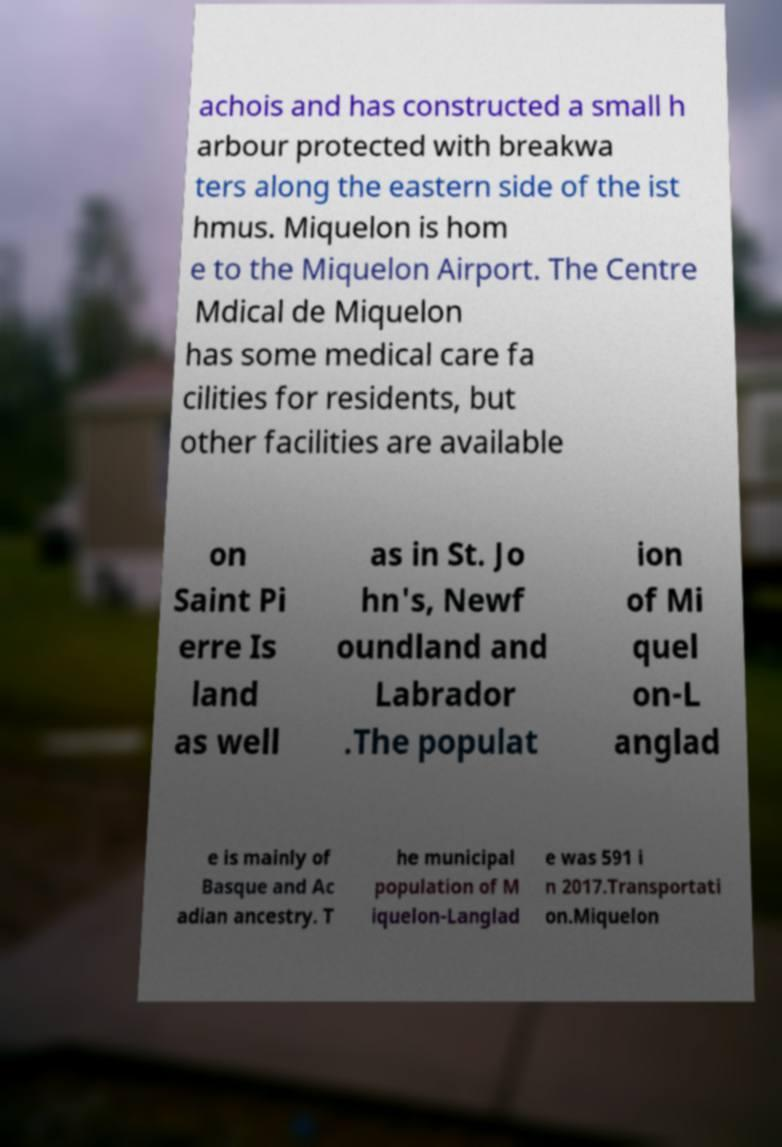Can you read and provide the text displayed in the image?This photo seems to have some interesting text. Can you extract and type it out for me? achois and has constructed a small h arbour protected with breakwa ters along the eastern side of the ist hmus. Miquelon is hom e to the Miquelon Airport. The Centre Mdical de Miquelon has some medical care fa cilities for residents, but other facilities are available on Saint Pi erre Is land as well as in St. Jo hn's, Newf oundland and Labrador .The populat ion of Mi quel on-L anglad e is mainly of Basque and Ac adian ancestry. T he municipal population of M iquelon-Langlad e was 591 i n 2017.Transportati on.Miquelon 